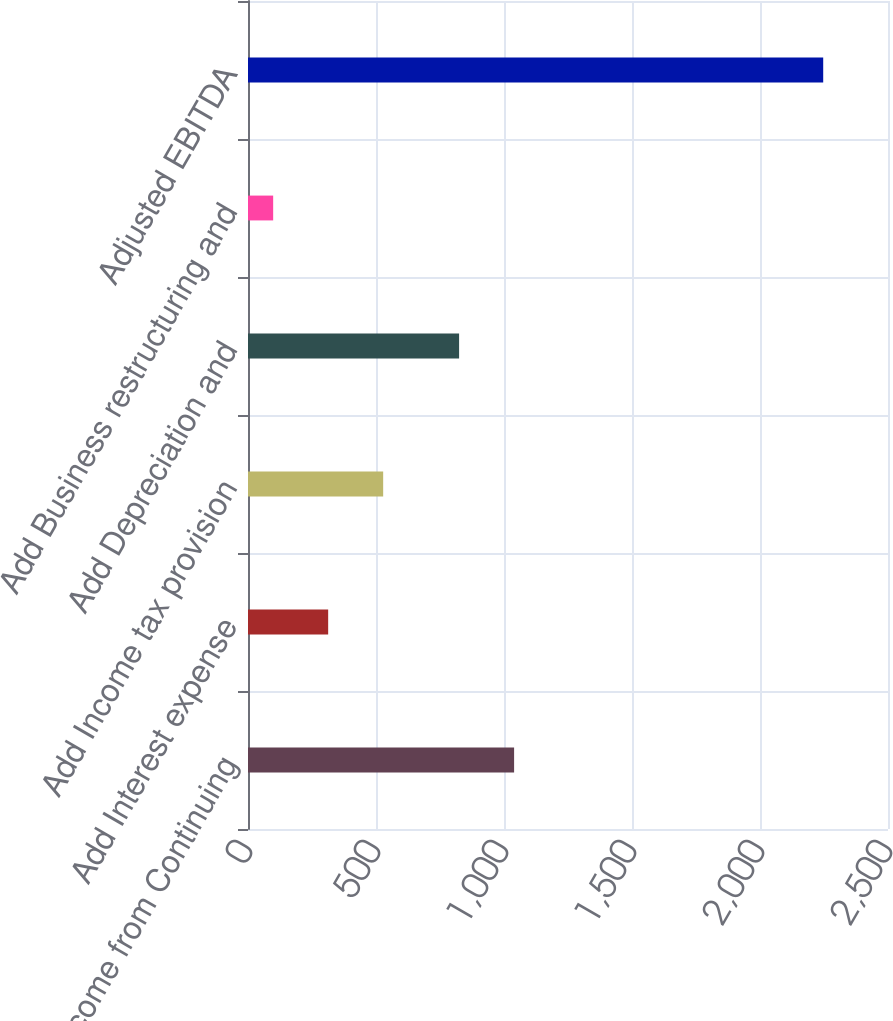<chart> <loc_0><loc_0><loc_500><loc_500><bar_chart><fcel>Income from Continuing<fcel>Add Interest expense<fcel>Add Income tax provision<fcel>Add Depreciation and<fcel>Add Business restructuring and<fcel>Adjusted EBITDA<nl><fcel>1039.46<fcel>313.16<fcel>528.02<fcel>824.6<fcel>98.3<fcel>2246.9<nl></chart> 